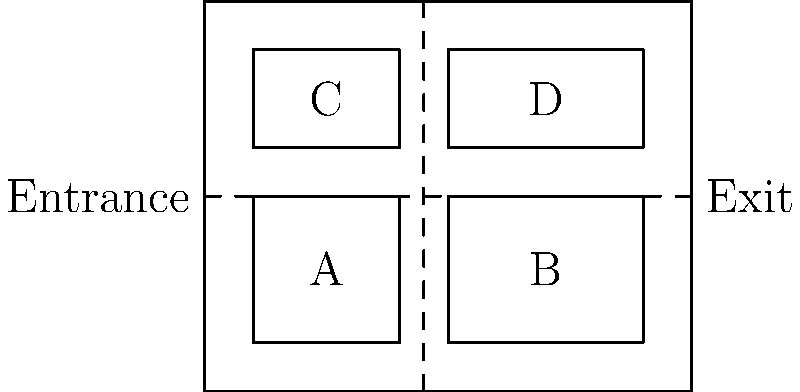Given the shelter layout above with four animal enclosures (A, B, C, and D) and dashed lines representing walkways, which arrangement of enclosures would be most efficient for guiding potential adopters through the shelter? Consider factors such as traffic flow and exposure to all animals. To determine the most efficient arrangement for guiding potential adopters through the shelter, we need to consider the following factors:

1. Traffic flow: The layout should allow for a smooth, logical progression through the shelter.
2. Exposure to all animals: Visitors should be able to see all enclosures easily.
3. Entrance and exit placement: The arrangement should make sense with the given entrance and exit locations.

Let's analyze the layout:

1. The entrance is on the left side, and the exit is on the right side of the shelter.
2. There are two main walkways: one horizontal in the middle and one vertical in the center.
3. The enclosures are arranged in a 2x2 grid pattern.

The most efficient arrangement would be:

1. Start with enclosure A (bottom-left) upon entering.
2. Move to enclosure B (bottom-right) following the horizontal walkway.
3. Turn left and use the vertical walkway to reach enclosure D (top-right).
4. Finally, move to enclosure C (top-left) before reaching the exit.

This arrangement creates a clockwise flow through the shelter, ensuring that visitors see all enclosures in a logical order without backtracking. It maximizes exposure to all animals while maintaining an efficient traffic flow from entrance to exit.

The optimal sequence of visiting enclosures would be: A → B → D → C
Answer: A → B → D → C 